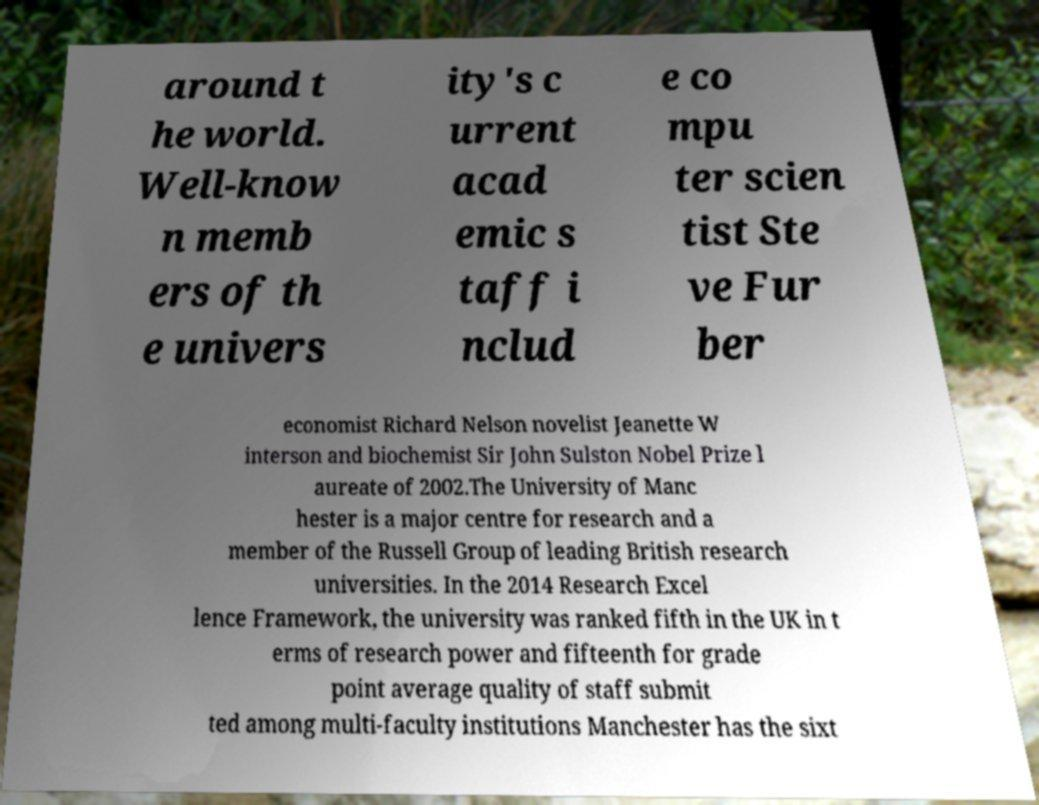What messages or text are displayed in this image? I need them in a readable, typed format. around t he world. Well-know n memb ers of th e univers ity's c urrent acad emic s taff i nclud e co mpu ter scien tist Ste ve Fur ber economist Richard Nelson novelist Jeanette W interson and biochemist Sir John Sulston Nobel Prize l aureate of 2002.The University of Manc hester is a major centre for research and a member of the Russell Group of leading British research universities. In the 2014 Research Excel lence Framework, the university was ranked fifth in the UK in t erms of research power and fifteenth for grade point average quality of staff submit ted among multi-faculty institutions Manchester has the sixt 